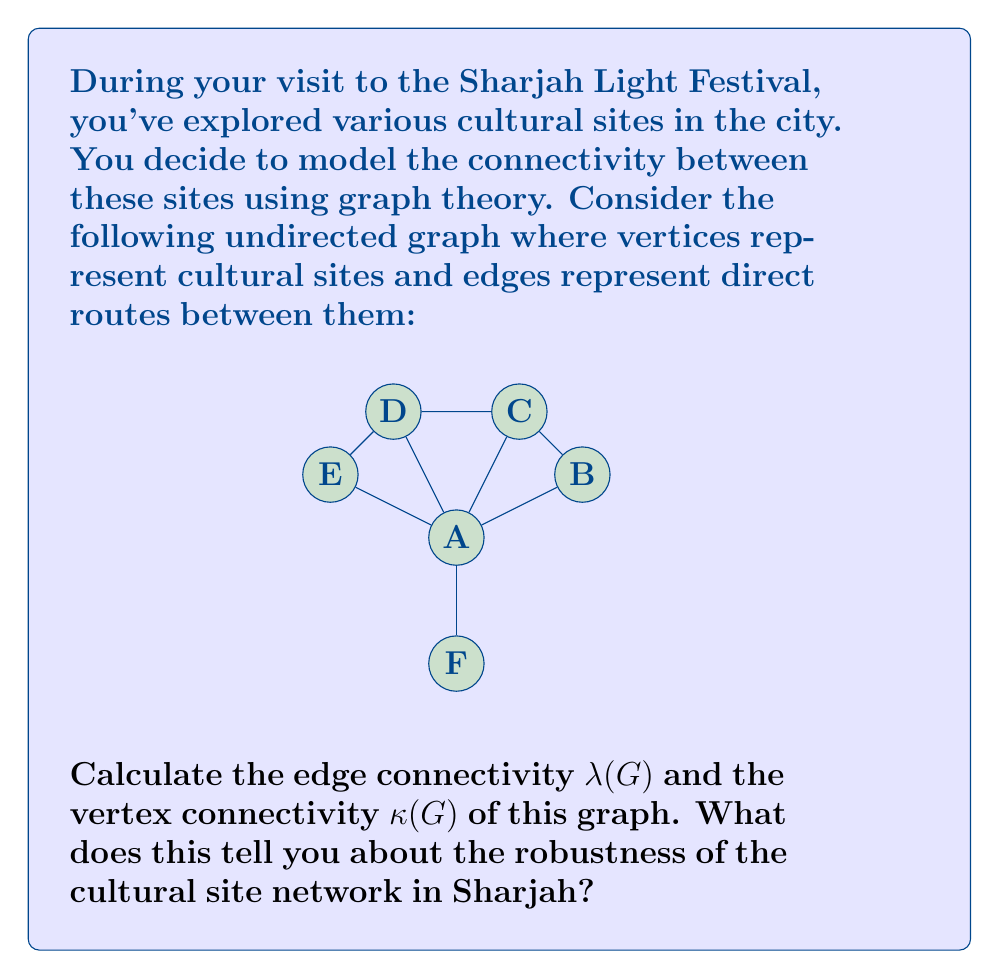Solve this math problem. To solve this problem, we need to understand the concepts of edge connectivity and vertex connectivity in graph theory:

1. Edge connectivity $\lambda(G)$: The minimum number of edges that need to be removed to disconnect the graph.
2. Vertex connectivity $\kappa(G)$: The minimum number of vertices that need to be removed to disconnect the graph or reduce it to a single vertex.

Let's analyze the graph:

1. Edge connectivity $\lambda(G)$:
   - The graph is connected, so $\lambda(G) \geq 1$.
   - Vertex A is connected to all other vertices, so removing all edges connected to A would disconnect the graph.
   - There are 5 edges connected to A, so $\lambda(G) \leq 5$.
   - However, removing the edges BC, CD, and DE would disconnect vertex F from the rest of the graph.
   - Therefore, $\lambda(G) = 3$.

2. Vertex connectivity $\kappa(G)$:
   - The graph is connected, so $\kappa(G) \geq 1$.
   - Removing vertex A would disconnect the graph.
   - There is no set of 2 vertices whose removal would disconnect the graph more than removing A alone.
   - Therefore, $\kappa(G) = 1$.

In general, for any graph G, we have the inequality:

$$\kappa(G) \leq \lambda(G) \leq \delta(G)$$

where $\delta(G)$ is the minimum degree of any vertex in the graph.

In this case, $\kappa(G) = 1 < \lambda(G) = 3 \leq \delta(G) = 3$, which satisfies the inequality.

Interpretation for the cultural site network in Sharjah:
1. The edge connectivity of 3 suggests that the network is moderately robust in terms of route connections. At least 3 routes need to be closed to completely disconnect the network.
2. The vertex connectivity of 1 indicates that the network is vulnerable to the closure of a single cultural site (specifically site A). If site A is closed, the network becomes disconnected.
3. The difference between edge and vertex connectivity suggests that while the route network is somewhat resilient, the centrality of site A is a potential weakness in the overall connectivity of cultural sites.
Answer: Edge connectivity: $\lambda(G) = 3$
Vertex connectivity: $\kappa(G) = 1$ 